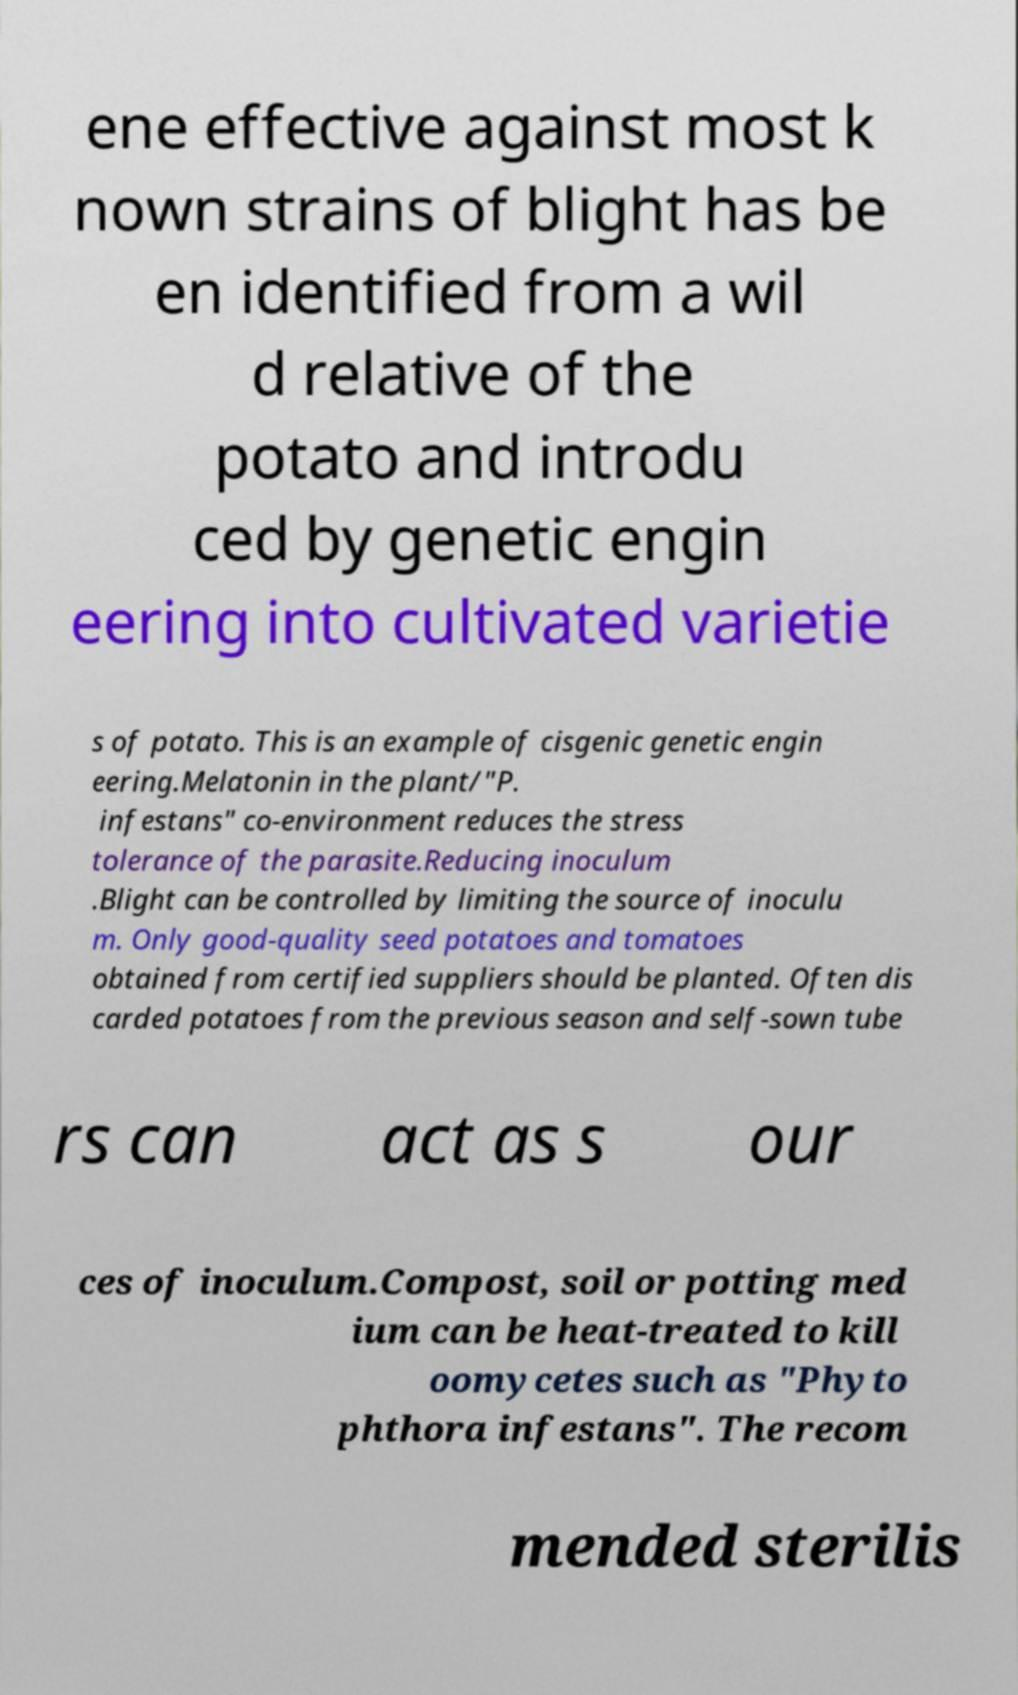Please read and relay the text visible in this image. What does it say? ene effective against most k nown strains of blight has be en identified from a wil d relative of the potato and introdu ced by genetic engin eering into cultivated varietie s of potato. This is an example of cisgenic genetic engin eering.Melatonin in the plant/"P. infestans" co-environment reduces the stress tolerance of the parasite.Reducing inoculum .Blight can be controlled by limiting the source of inoculu m. Only good-quality seed potatoes and tomatoes obtained from certified suppliers should be planted. Often dis carded potatoes from the previous season and self-sown tube rs can act as s our ces of inoculum.Compost, soil or potting med ium can be heat-treated to kill oomycetes such as "Phyto phthora infestans". The recom mended sterilis 